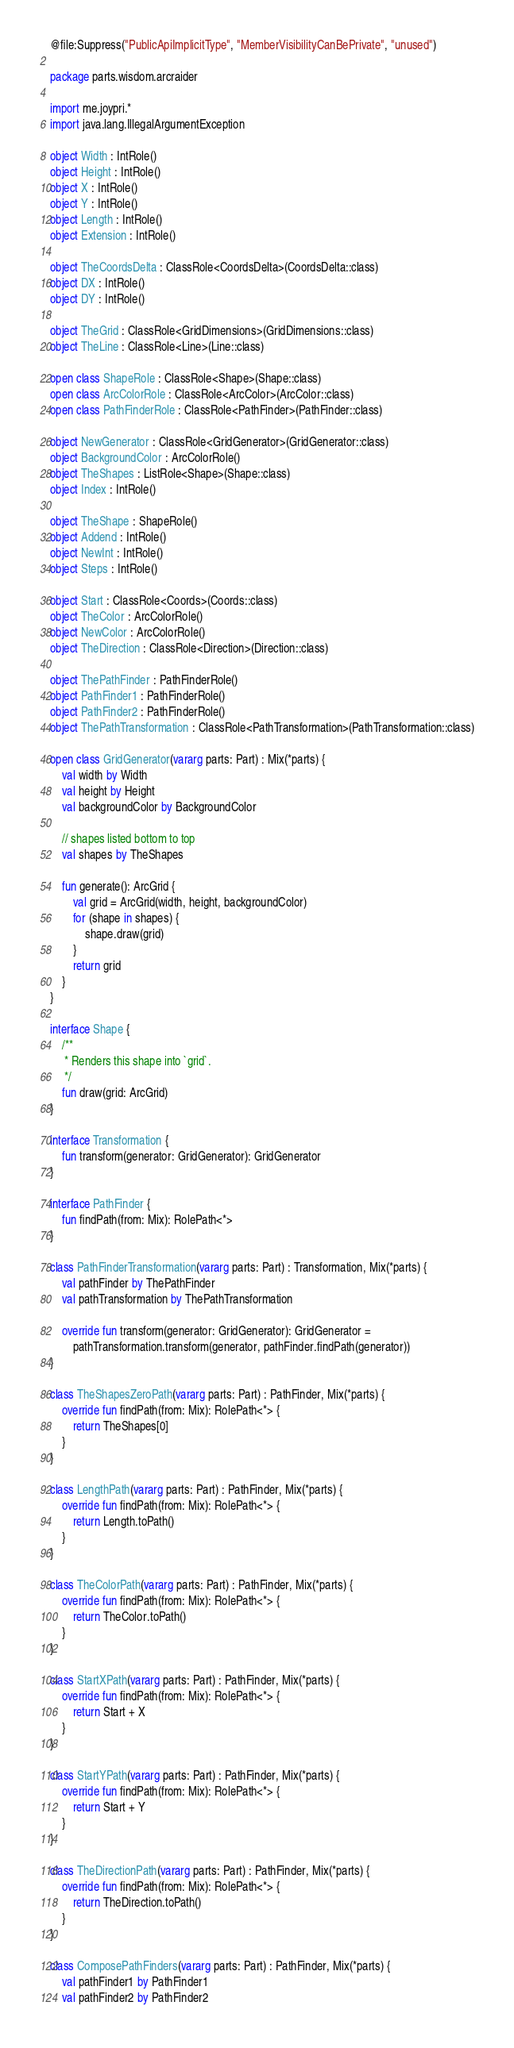Convert code to text. <code><loc_0><loc_0><loc_500><loc_500><_Kotlin_>@file:Suppress("PublicApiImplicitType", "MemberVisibilityCanBePrivate", "unused")

package parts.wisdom.arcraider

import me.joypri.*
import java.lang.IllegalArgumentException

object Width : IntRole()
object Height : IntRole()
object X : IntRole()
object Y : IntRole()
object Length : IntRole()
object Extension : IntRole()

object TheCoordsDelta : ClassRole<CoordsDelta>(CoordsDelta::class)
object DX : IntRole()
object DY : IntRole()

object TheGrid : ClassRole<GridDimensions>(GridDimensions::class)
object TheLine : ClassRole<Line>(Line::class)

open class ShapeRole : ClassRole<Shape>(Shape::class)
open class ArcColorRole : ClassRole<ArcColor>(ArcColor::class)
open class PathFinderRole : ClassRole<PathFinder>(PathFinder::class)

object NewGenerator : ClassRole<GridGenerator>(GridGenerator::class)
object BackgroundColor : ArcColorRole()
object TheShapes : ListRole<Shape>(Shape::class)
object Index : IntRole()

object TheShape : ShapeRole()
object Addend : IntRole()
object NewInt : IntRole()
object Steps : IntRole()

object Start : ClassRole<Coords>(Coords::class)
object TheColor : ArcColorRole()
object NewColor : ArcColorRole()
object TheDirection : ClassRole<Direction>(Direction::class)

object ThePathFinder : PathFinderRole()
object PathFinder1 : PathFinderRole()
object PathFinder2 : PathFinderRole()
object ThePathTransformation : ClassRole<PathTransformation>(PathTransformation::class)

open class GridGenerator(vararg parts: Part) : Mix(*parts) {
    val width by Width
    val height by Height
    val backgroundColor by BackgroundColor

    // shapes listed bottom to top
    val shapes by TheShapes

    fun generate(): ArcGrid {
        val grid = ArcGrid(width, height, backgroundColor)
        for (shape in shapes) {
            shape.draw(grid)
        }
        return grid
    }
}

interface Shape {
    /**
     * Renders this shape into `grid`.
     */
    fun draw(grid: ArcGrid)
}

interface Transformation {
    fun transform(generator: GridGenerator): GridGenerator
}

interface PathFinder {
    fun findPath(from: Mix): RolePath<*>
}

class PathFinderTransformation(vararg parts: Part) : Transformation, Mix(*parts) {
    val pathFinder by ThePathFinder
    val pathTransformation by ThePathTransformation

    override fun transform(generator: GridGenerator): GridGenerator =
        pathTransformation.transform(generator, pathFinder.findPath(generator))
}

class TheShapesZeroPath(vararg parts: Part) : PathFinder, Mix(*parts) {
    override fun findPath(from: Mix): RolePath<*> {
        return TheShapes[0]
    }
}

class LengthPath(vararg parts: Part) : PathFinder, Mix(*parts) {
    override fun findPath(from: Mix): RolePath<*> {
        return Length.toPath()
    }
}

class TheColorPath(vararg parts: Part) : PathFinder, Mix(*parts) {
    override fun findPath(from: Mix): RolePath<*> {
        return TheColor.toPath()
    }
}

class StartXPath(vararg parts: Part) : PathFinder, Mix(*parts) {
    override fun findPath(from: Mix): RolePath<*> {
        return Start + X
    }
}

class StartYPath(vararg parts: Part) : PathFinder, Mix(*parts) {
    override fun findPath(from: Mix): RolePath<*> {
        return Start + Y
    }
}

class TheDirectionPath(vararg parts: Part) : PathFinder, Mix(*parts) {
    override fun findPath(from: Mix): RolePath<*> {
        return TheDirection.toPath()
    }
}

class ComposePathFinders(vararg parts: Part) : PathFinder, Mix(*parts) {
    val pathFinder1 by PathFinder1
    val pathFinder2 by PathFinder2
</code> 